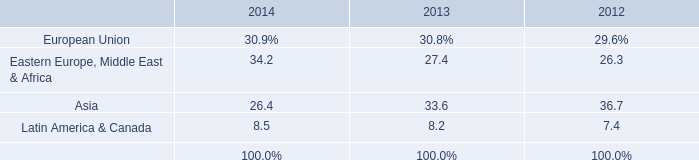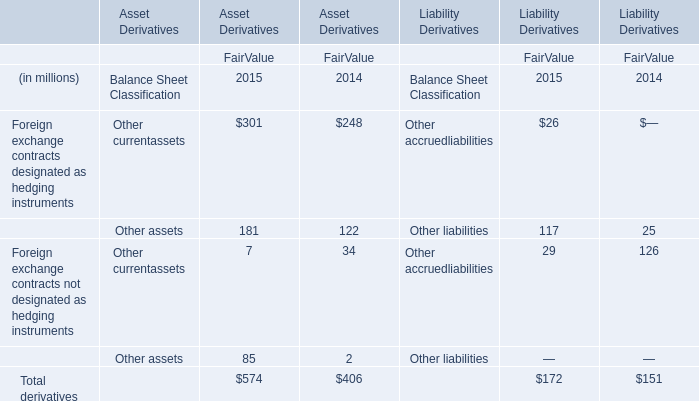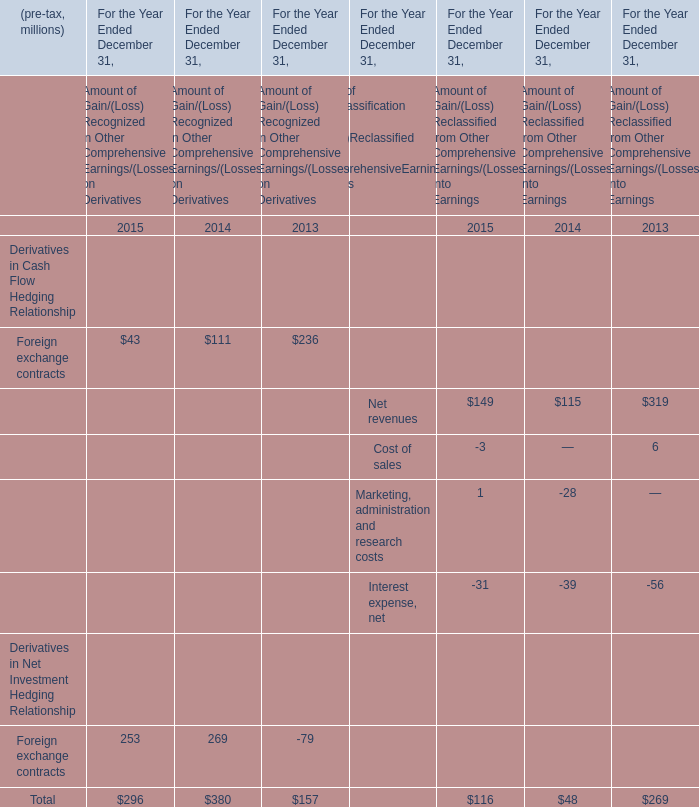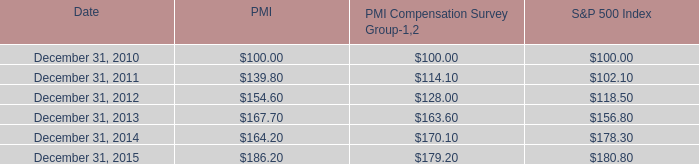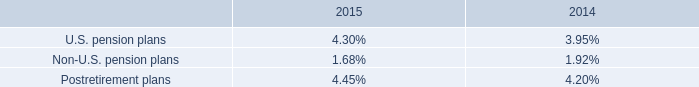what was the change in billions of total debt from december 31 , 2014 to 2015? 
Computations: (28.5 - 29.5)
Answer: -1.0. 